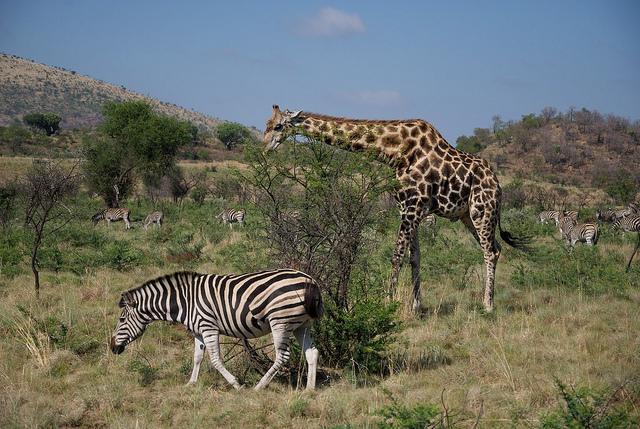Which animals are these?
Concise answer only. Zebra and giraffe. What other animal is in the picture?
Keep it brief. Giraffe. What colors are the animals?
Write a very short answer. Black and white and brown. What animal is this?
Answer briefly. Zebra. Is it winter?
Keep it brief. No. What is the zebra doing?
Answer briefly. Walking. 